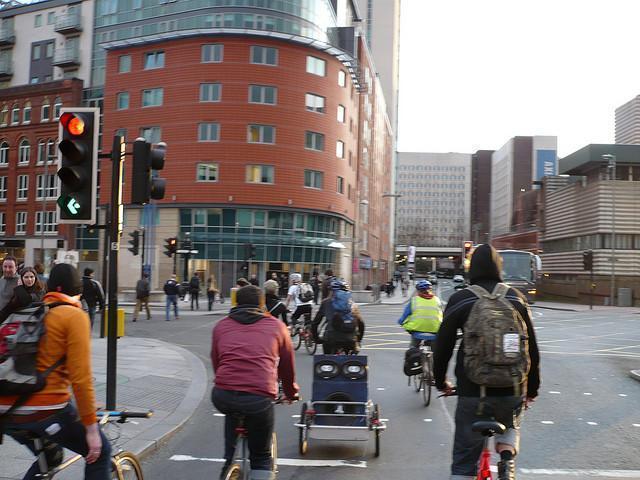What type of action is allowed by the traffic light?
Pick the correct solution from the four options below to address the question.
Options: Straight travel, left turn, pedestrian crossing, right turn. Left turn. 